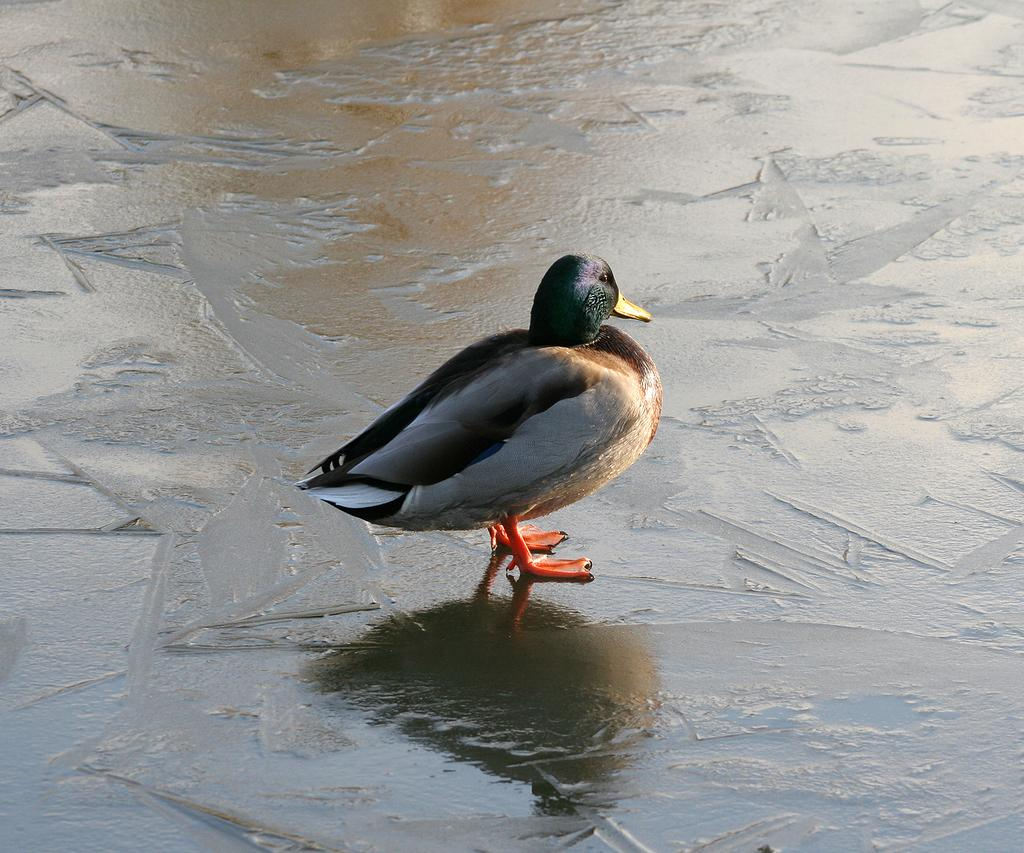What type of animal is present in the image? There is a bird in the image. Where is the bird located in the image? The bird is on the wet ground. What color is the pocket on the bird's back in the image? There is no pocket on the bird's back in the image, as birds do not have pockets. 